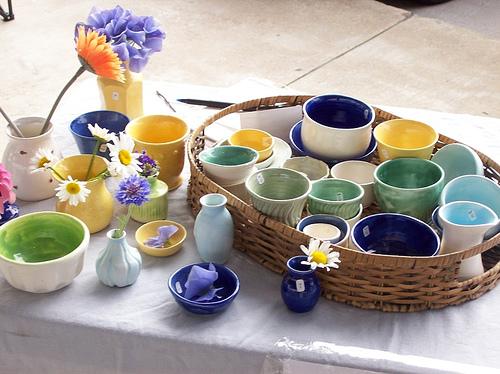Which bowl has the most flowers in it?
Answer briefly. Yellow bowl. Is this a fall flower pictured?
Concise answer only. No. Was ceramic glaze or acrylic paint used to decorate these objects?
Short answer required. Yes. How many vases are in this picture?
Short answer required. 6. How many plants are in vases?
Write a very short answer. 5. 